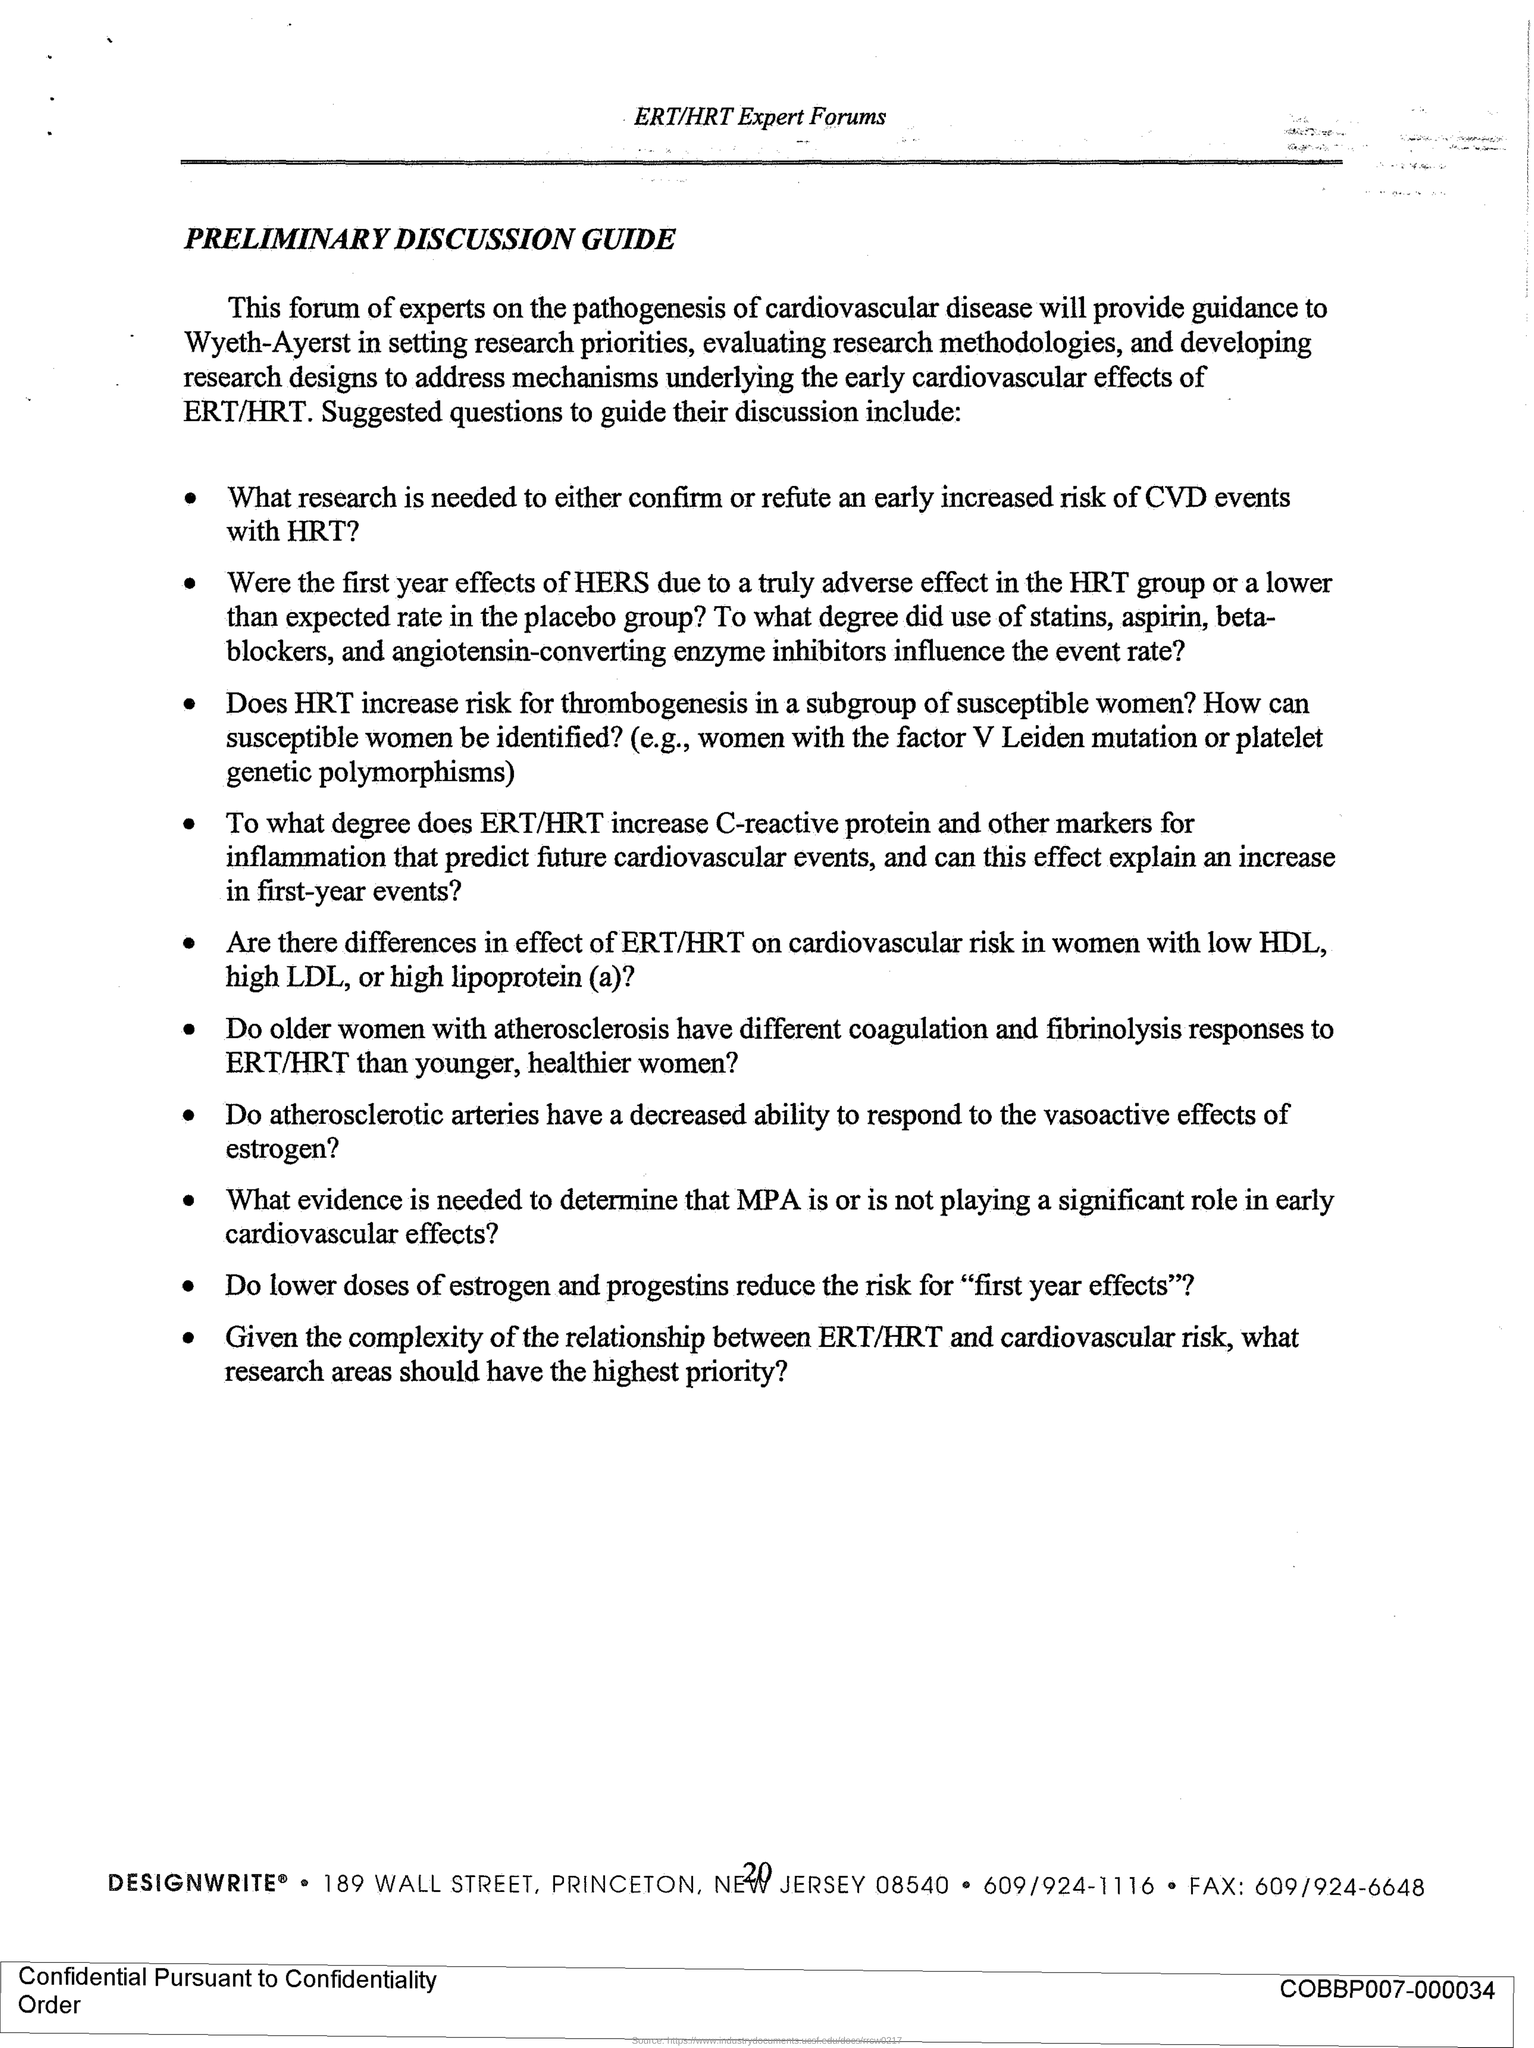Highlight a few significant elements in this photo. The title of the document is 'PRELIMINARY DISCUSSION GUIDE.' I would like to know the page number, specifically 20. The fax number is 609/924-6648. 